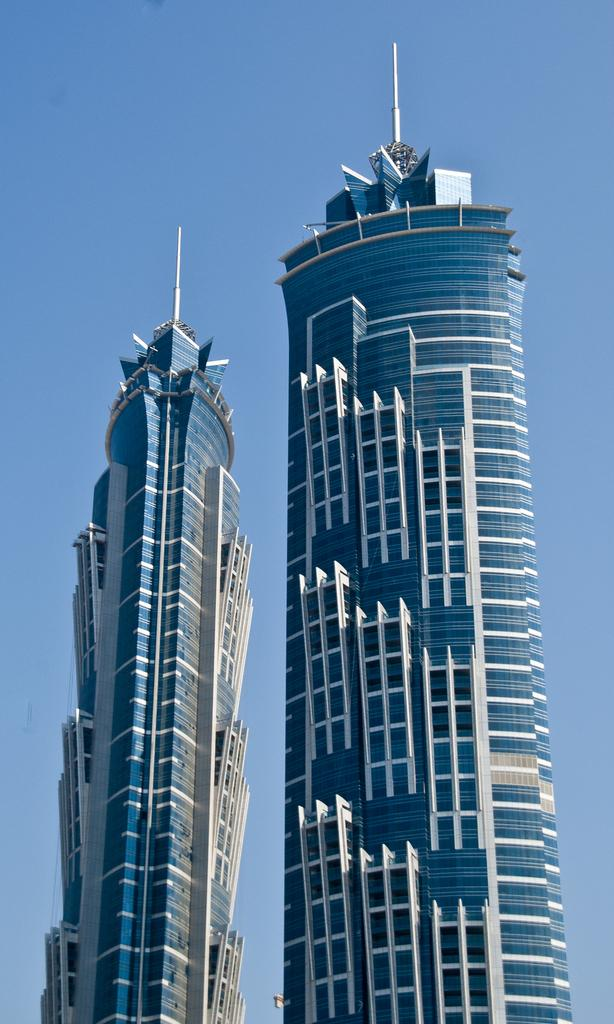What type of structures can be seen in the image? There are buildings in the image. What type of silverware is being used by the dinosaurs in the image? There are no dinosaurs or silverware present in the image; it only features buildings. How many pies can be seen on top of the buildings in the image? There are no pies visible on top of the buildings in the image. 